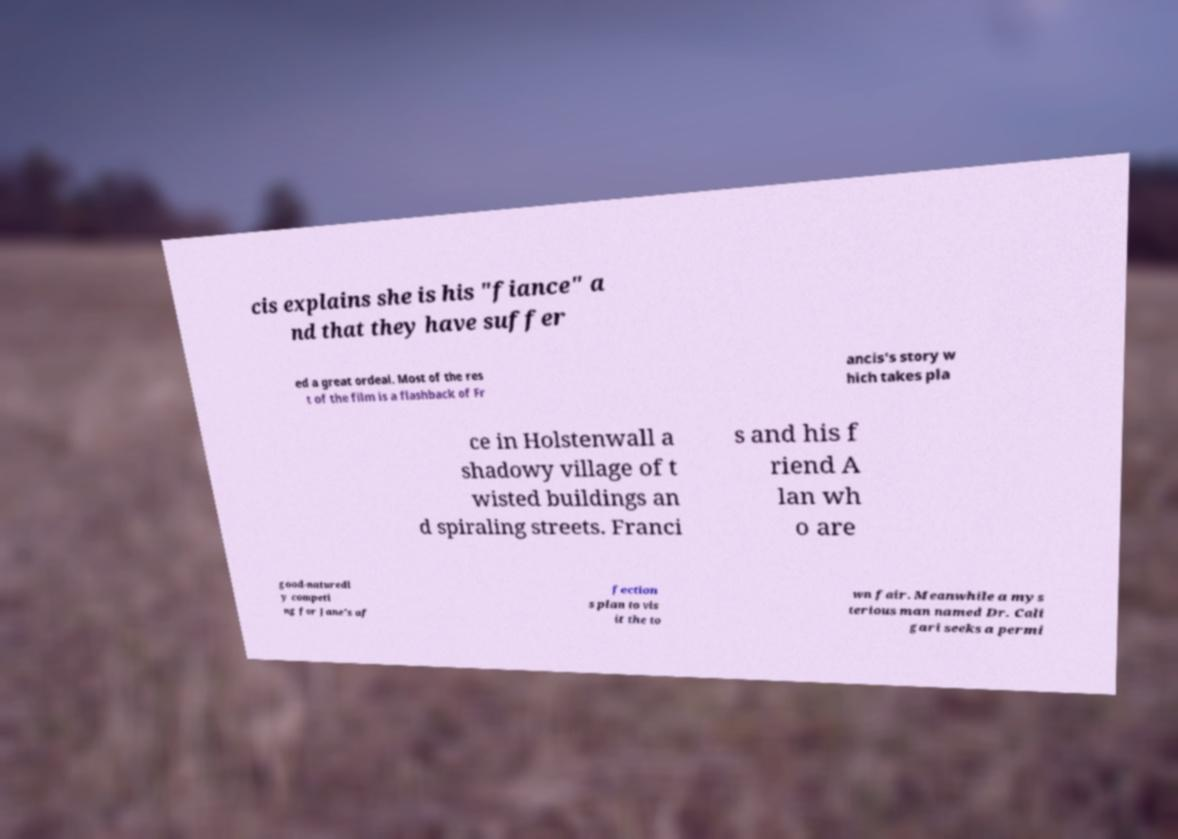What messages or text are displayed in this image? I need them in a readable, typed format. cis explains she is his "fiance" a nd that they have suffer ed a great ordeal. Most of the res t of the film is a flashback of Fr ancis's story w hich takes pla ce in Holstenwall a shadowy village of t wisted buildings an d spiraling streets. Franci s and his f riend A lan wh o are good-naturedl y competi ng for Jane's af fection s plan to vis it the to wn fair. Meanwhile a mys terious man named Dr. Cali gari seeks a permi 